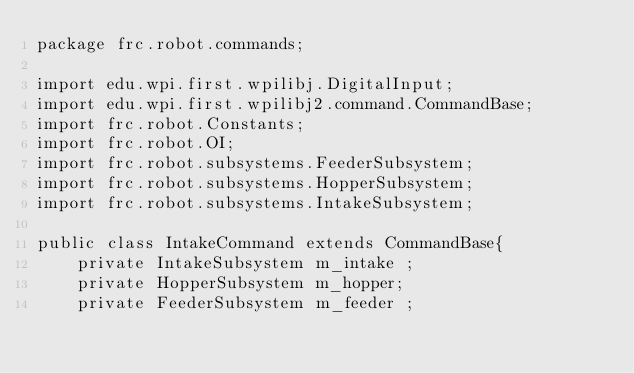Convert code to text. <code><loc_0><loc_0><loc_500><loc_500><_Java_>package frc.robot.commands;

import edu.wpi.first.wpilibj.DigitalInput;
import edu.wpi.first.wpilibj2.command.CommandBase;
import frc.robot.Constants;
import frc.robot.OI;
import frc.robot.subsystems.FeederSubsystem;
import frc.robot.subsystems.HopperSubsystem;
import frc.robot.subsystems.IntakeSubsystem;

public class IntakeCommand extends CommandBase{
    private IntakeSubsystem m_intake ;
    private HopperSubsystem m_hopper;
    private FeederSubsystem m_feeder ;</code> 